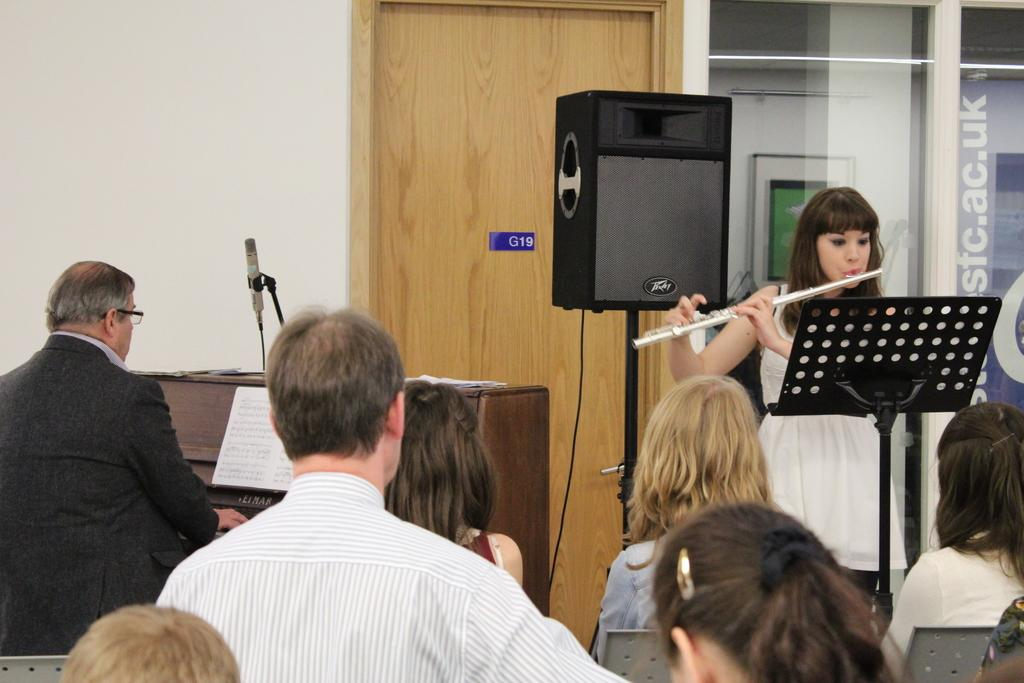What is the color of the wall in the image? The wall in the image is white. What feature can be used to enter or exit a room in the image? There is a door in the image. What device is present in the image that is used for amplifying sound? There is a sound box in the image. Who are the individuals in the image? There are people standing in the image. What activity is the woman engaged in within the image? A woman is playing a musical instrument in the image. Can you see a squirrel climbing on the door in the image? There is no squirrel present in the image, and the door is not being climbed on. What type of nose is the woman playing the musical instrument using to play the instrument? The woman is using her hands to play the musical instrument, not her nose. 